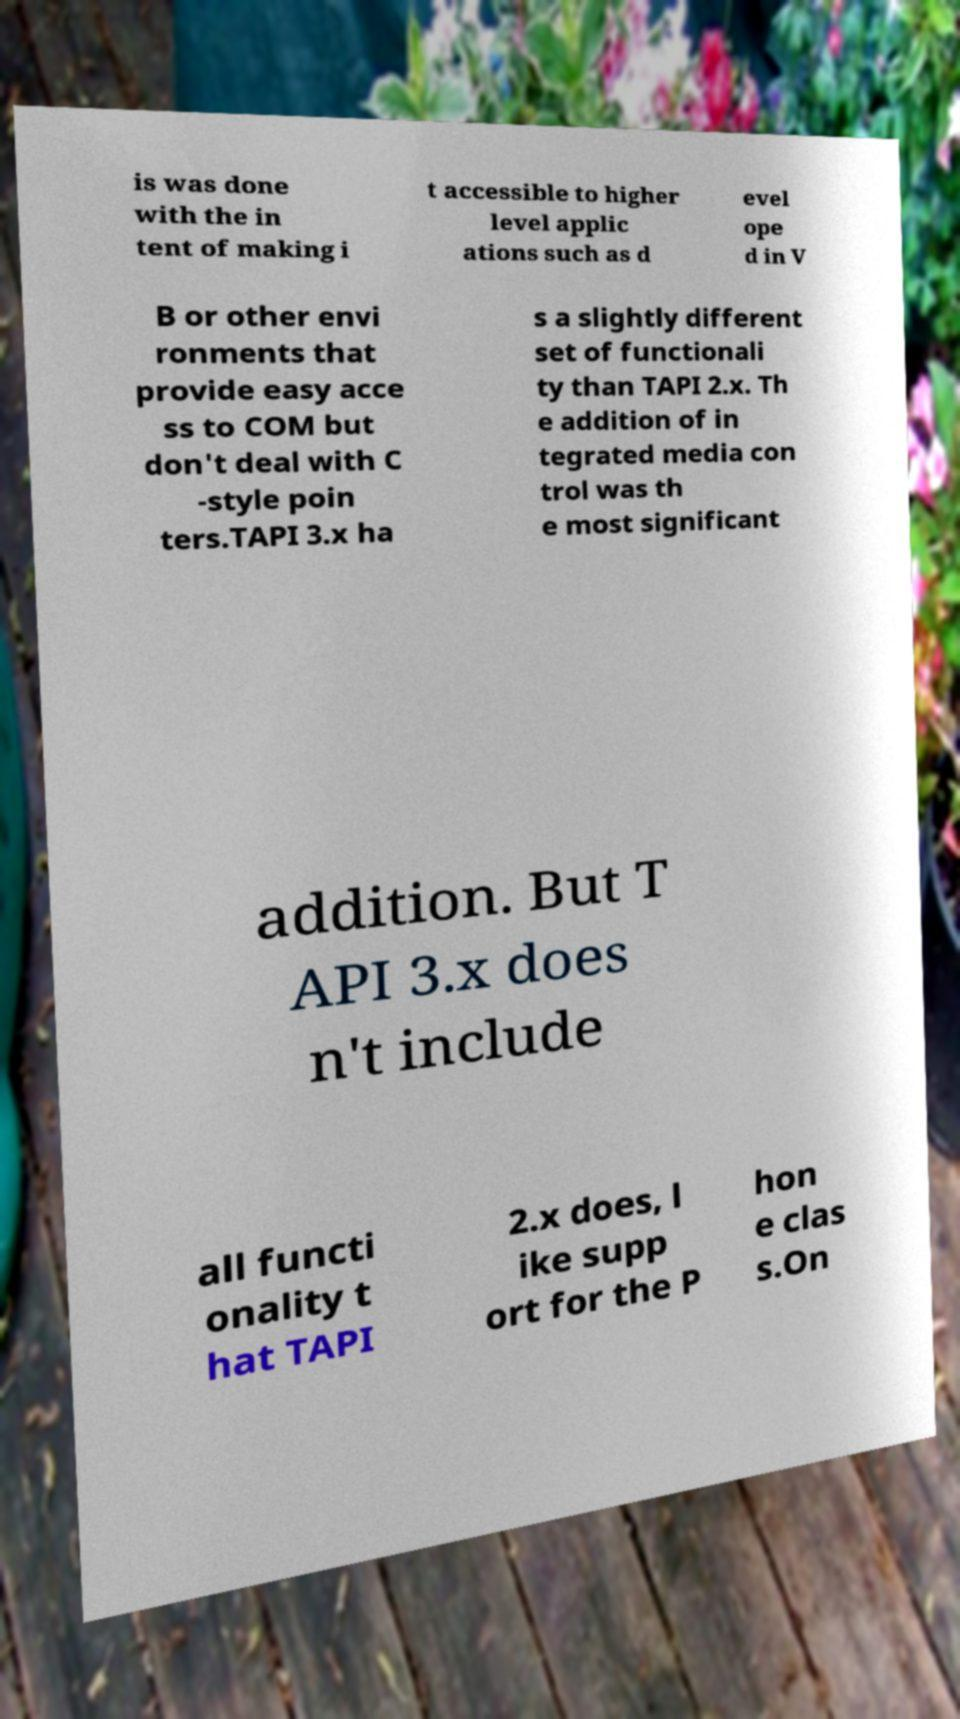What messages or text are displayed in this image? I need them in a readable, typed format. is was done with the in tent of making i t accessible to higher level applic ations such as d evel ope d in V B or other envi ronments that provide easy acce ss to COM but don't deal with C -style poin ters.TAPI 3.x ha s a slightly different set of functionali ty than TAPI 2.x. Th e addition of in tegrated media con trol was th e most significant addition. But T API 3.x does n't include all functi onality t hat TAPI 2.x does, l ike supp ort for the P hon e clas s.On 